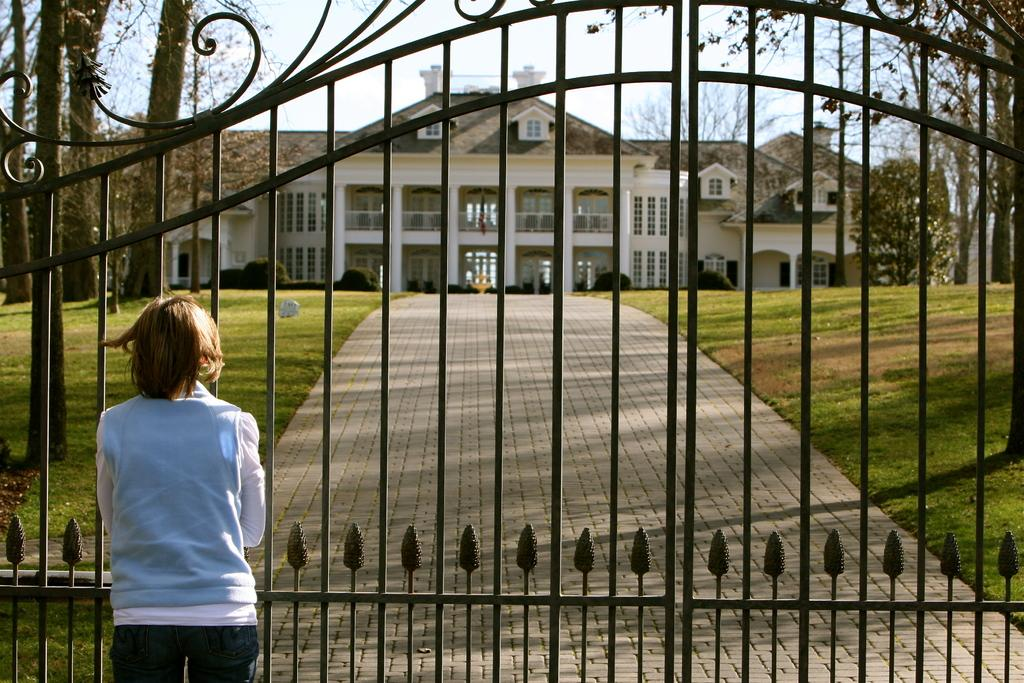What is the person in the image doing? The person is standing in front of the gate. What structure can be seen in the background of the image? There is a building visible in the image. What type of vegetation is present in the image? There are trees and plants in the image. What type of baseball event is taking place in the image? There is no baseball event present in the image. What type of table is visible in the image? There is no table visible in the image. 